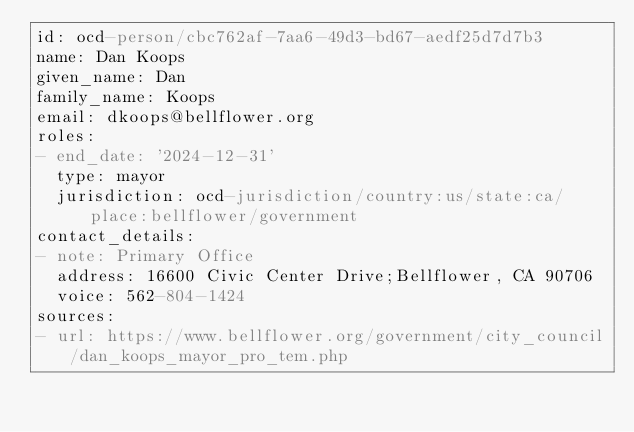<code> <loc_0><loc_0><loc_500><loc_500><_YAML_>id: ocd-person/cbc762af-7aa6-49d3-bd67-aedf25d7d7b3
name: Dan Koops
given_name: Dan
family_name: Koops
email: dkoops@bellflower.org
roles:
- end_date: '2024-12-31'
  type: mayor
  jurisdiction: ocd-jurisdiction/country:us/state:ca/place:bellflower/government
contact_details:
- note: Primary Office
  address: 16600 Civic Center Drive;Bellflower, CA 90706
  voice: 562-804-1424
sources:
- url: https://www.bellflower.org/government/city_council/dan_koops_mayor_pro_tem.php
</code> 